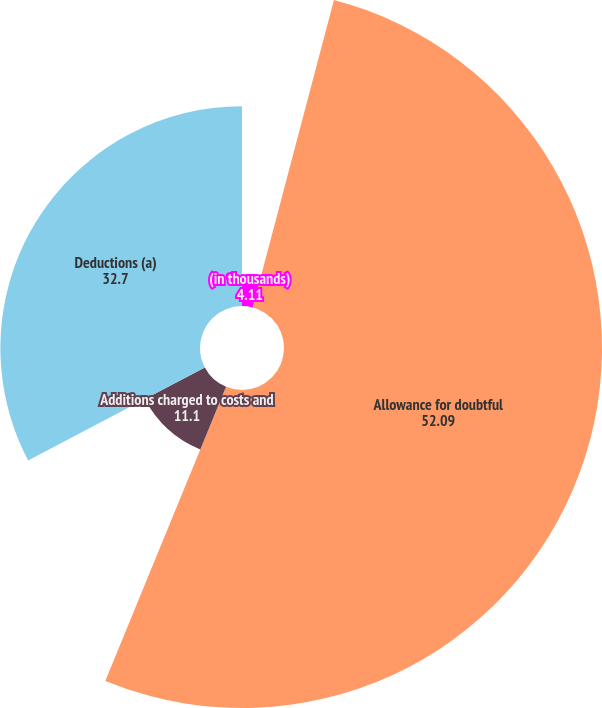Convert chart to OTSL. <chart><loc_0><loc_0><loc_500><loc_500><pie_chart><fcel>(in thousands)<fcel>Allowance for doubtful<fcel>Additions charged to costs and<fcel>Deductions (a)<nl><fcel>4.11%<fcel>52.09%<fcel>11.1%<fcel>32.7%<nl></chart> 